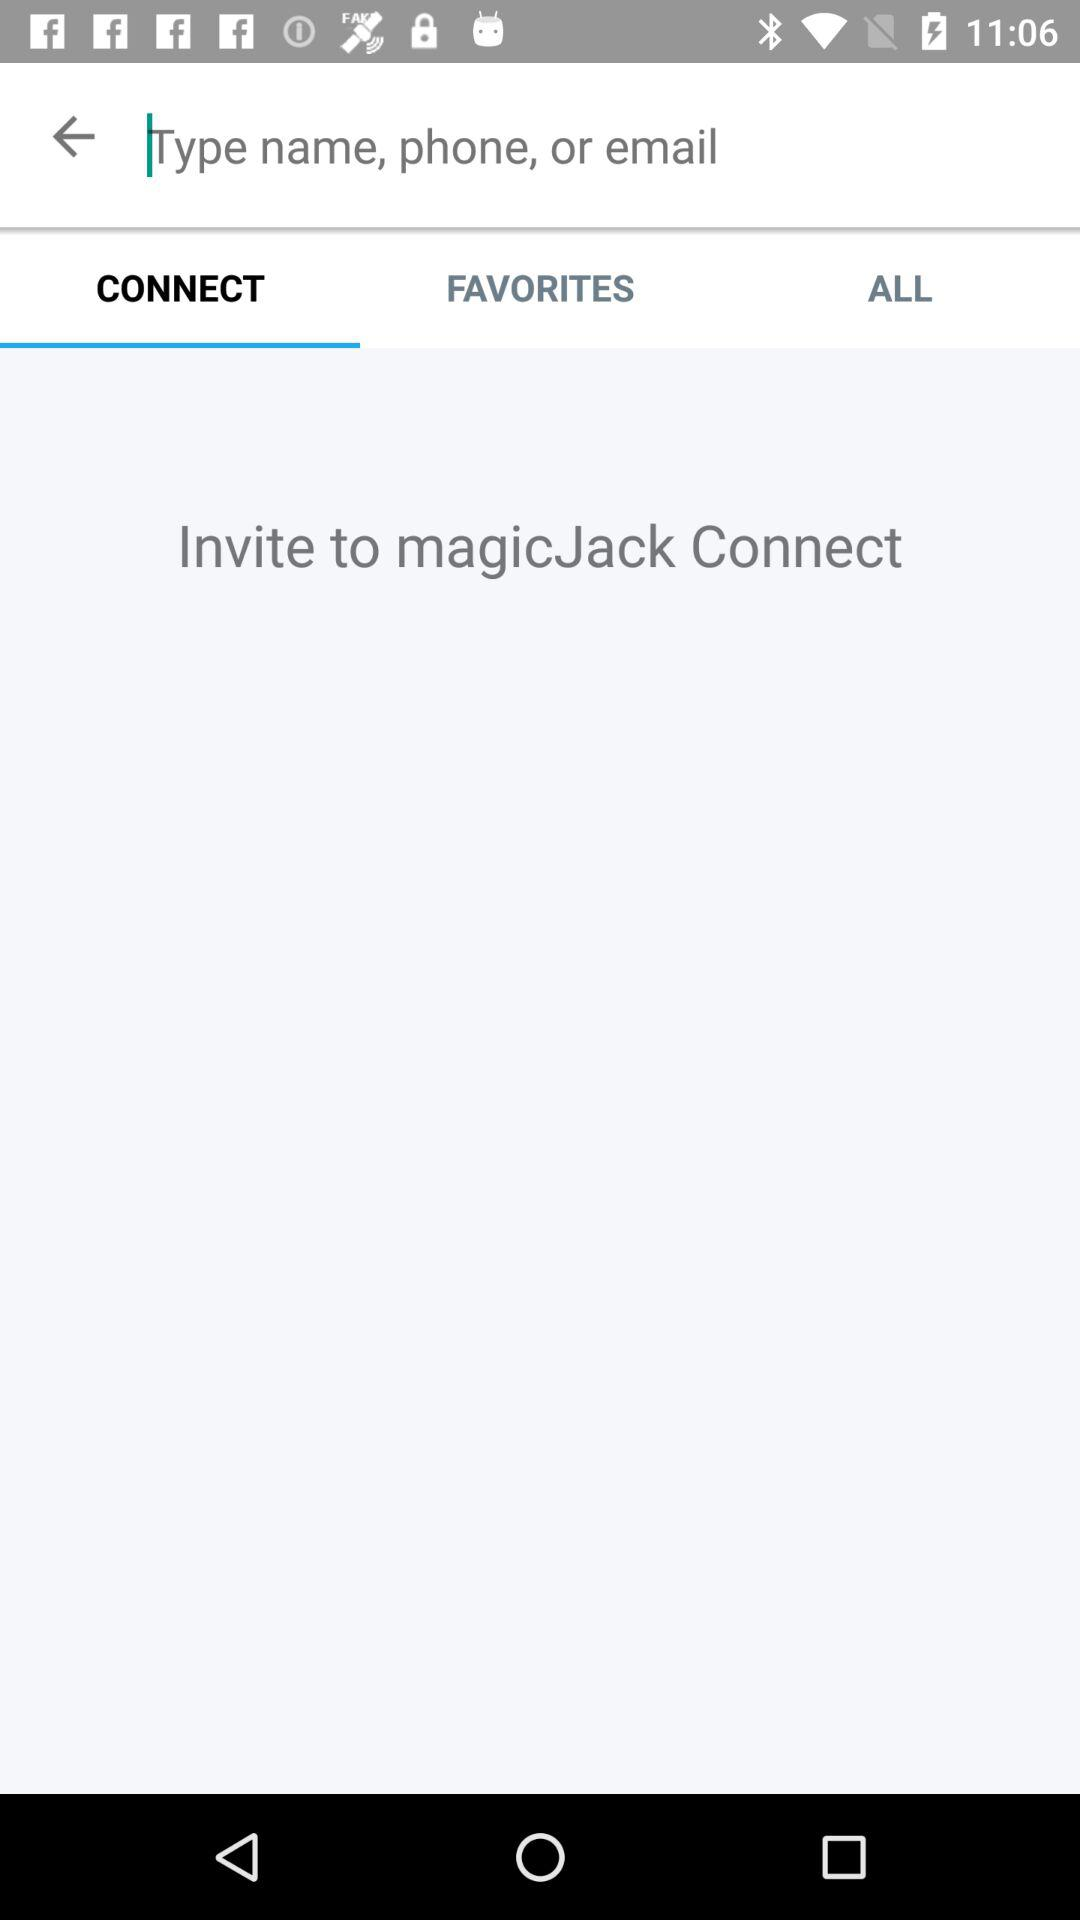Which tab is currently selected? The currently selected tab is "CONNECT". 